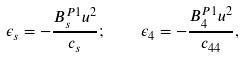Convert formula to latex. <formula><loc_0><loc_0><loc_500><loc_500>\epsilon _ { s } = - \frac { B ^ { P 1 } _ { s } u ^ { 2 } } { c _ { s } } ; \quad \epsilon _ { 4 } = - \frac { B ^ { P 1 } _ { 4 } u ^ { 2 } } { c _ { 4 4 } } ,</formula> 